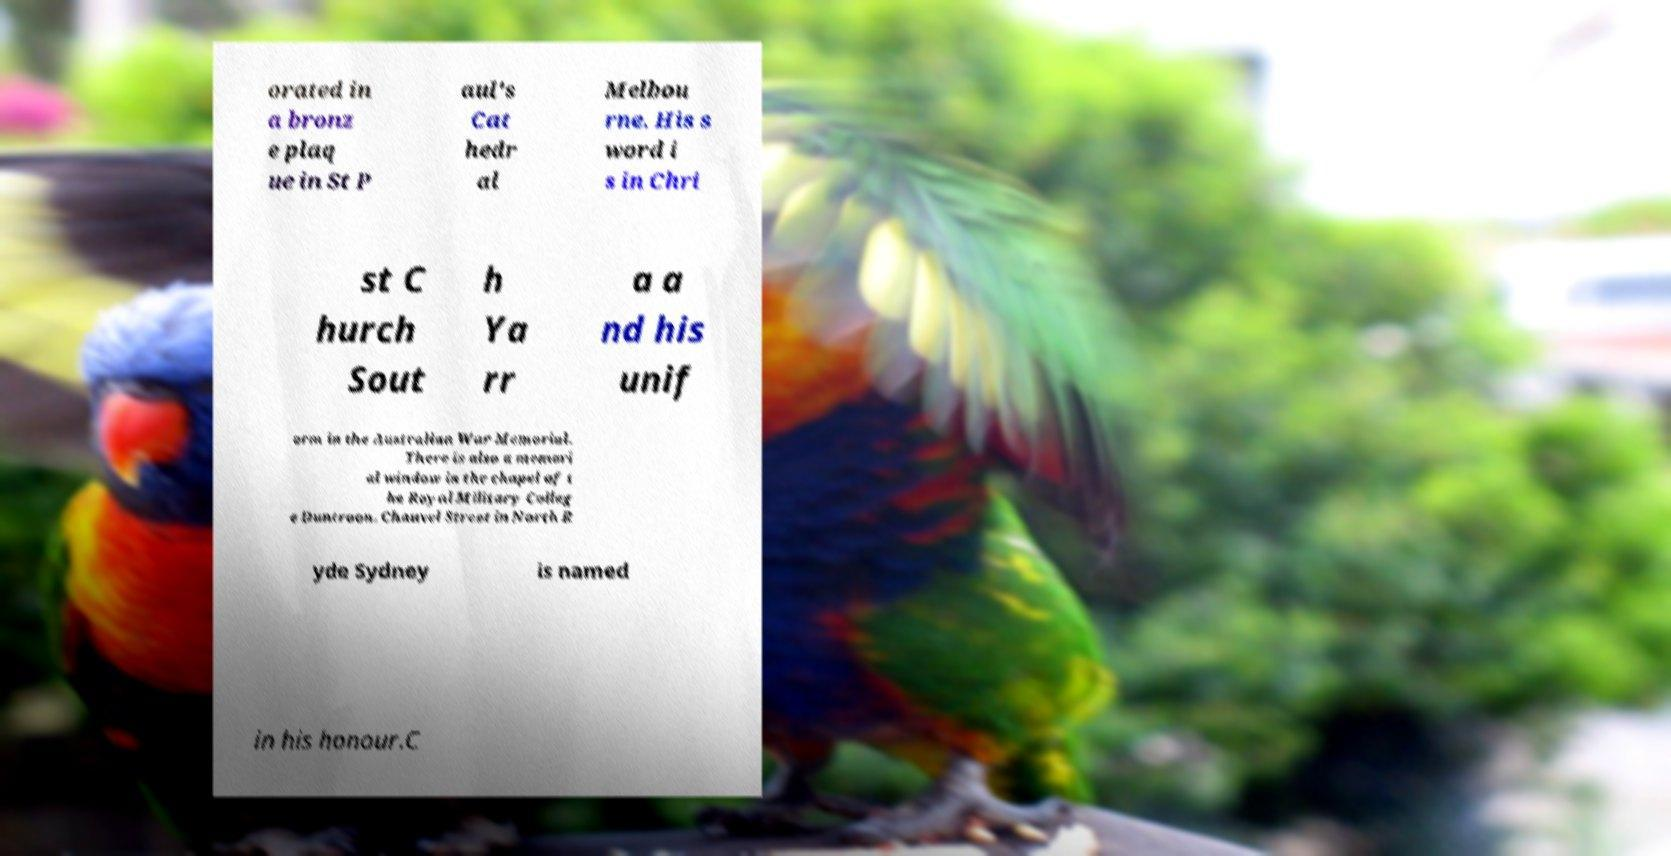There's text embedded in this image that I need extracted. Can you transcribe it verbatim? orated in a bronz e plaq ue in St P aul's Cat hedr al Melbou rne. His s word i s in Chri st C hurch Sout h Ya rr a a nd his unif orm in the Australian War Memorial. There is also a memori al window in the chapel of t he Royal Military Colleg e Duntroon. Chauvel Street in North R yde Sydney is named in his honour.C 